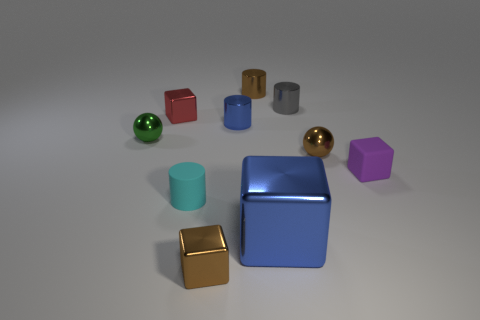Subtract all small matte blocks. How many blocks are left? 3 Subtract all gray cylinders. How many cylinders are left? 3 Subtract all yellow spheres. How many blue blocks are left? 1 Subtract 2 cylinders. How many cylinders are left? 2 Subtract all red cylinders. Subtract all big metal things. How many objects are left? 9 Add 3 tiny red metallic things. How many tiny red metallic things are left? 4 Add 9 red blocks. How many red blocks exist? 10 Subtract 0 purple cylinders. How many objects are left? 10 Subtract all blocks. How many objects are left? 6 Subtract all red cubes. Subtract all cyan balls. How many cubes are left? 3 